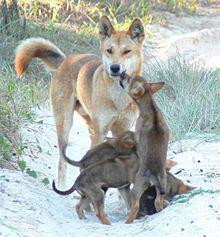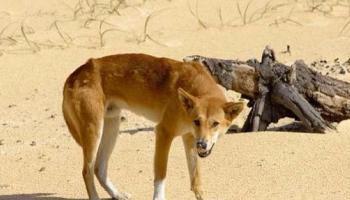The first image is the image on the left, the second image is the image on the right. For the images displayed, is the sentence "The right image includes more than twice the number of dogs as the left image." factually correct? Answer yes or no. No. 